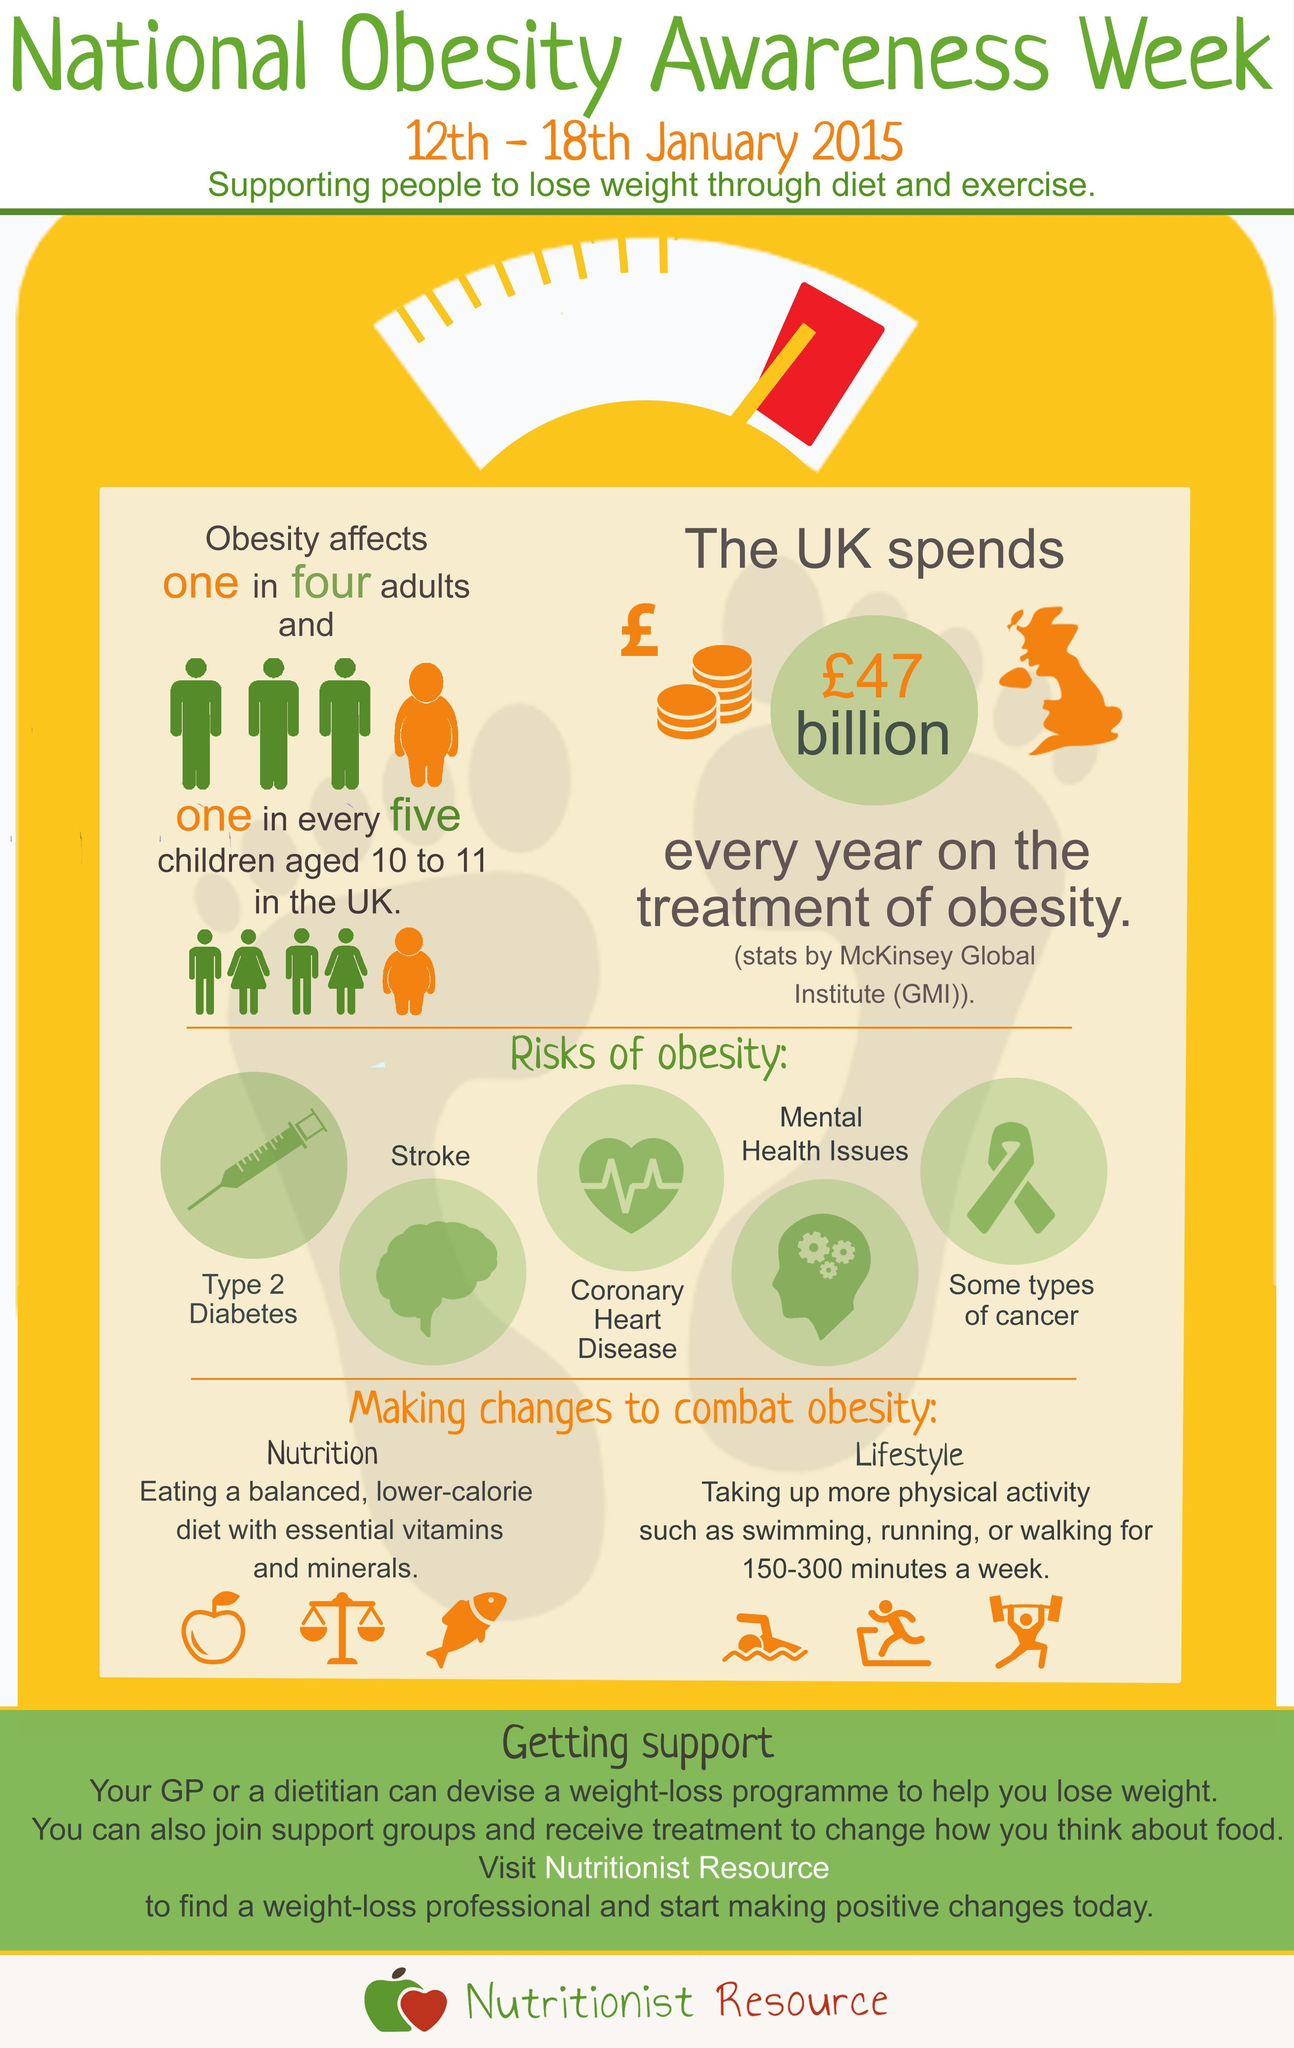What physical activities should be included to keep obesity away ?
Answer the question with a short phrase. Swimming, running, walking What does the image of a syringe represent - type 2 diabetes, stroke or cancer ? Type 2 diabetes What is the colour used to represent the image of a female - green, yellow, orange or white ? ? Orange What disease is represented by the image of a heart? Coronary heart disease What should be included in a balanced low calorie diet in order to combat obesity ? Vitamins and minerals Which lifestyle disease is common in one in five children in UK ? Obesity 